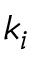Convert formula to latex. <formula><loc_0><loc_0><loc_500><loc_500>k _ { i }</formula> 